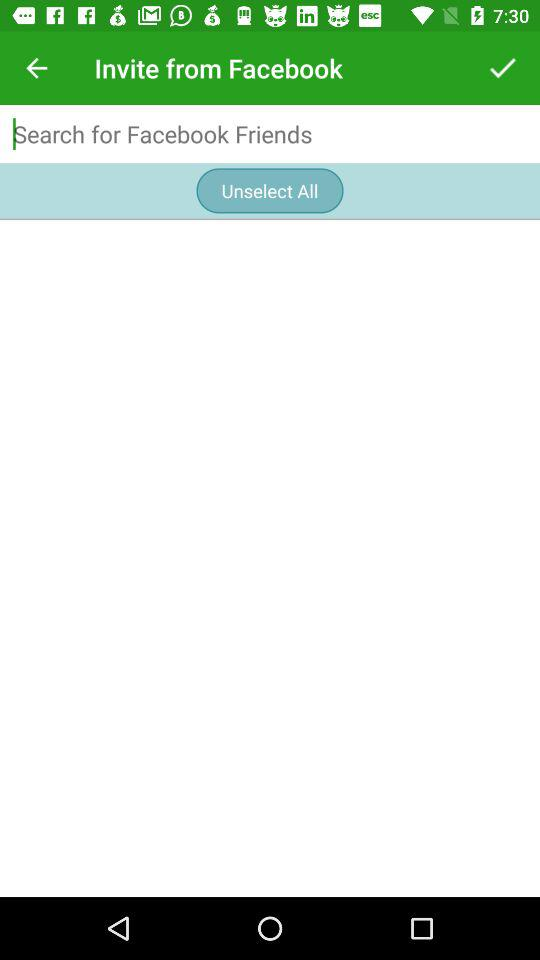From what application can the user invite friends? The user can invite friends from "Facebook". 